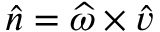Convert formula to latex. <formula><loc_0><loc_0><loc_500><loc_500>\widehat { n } = \widehat { \omega } \times \widehat { v }</formula> 